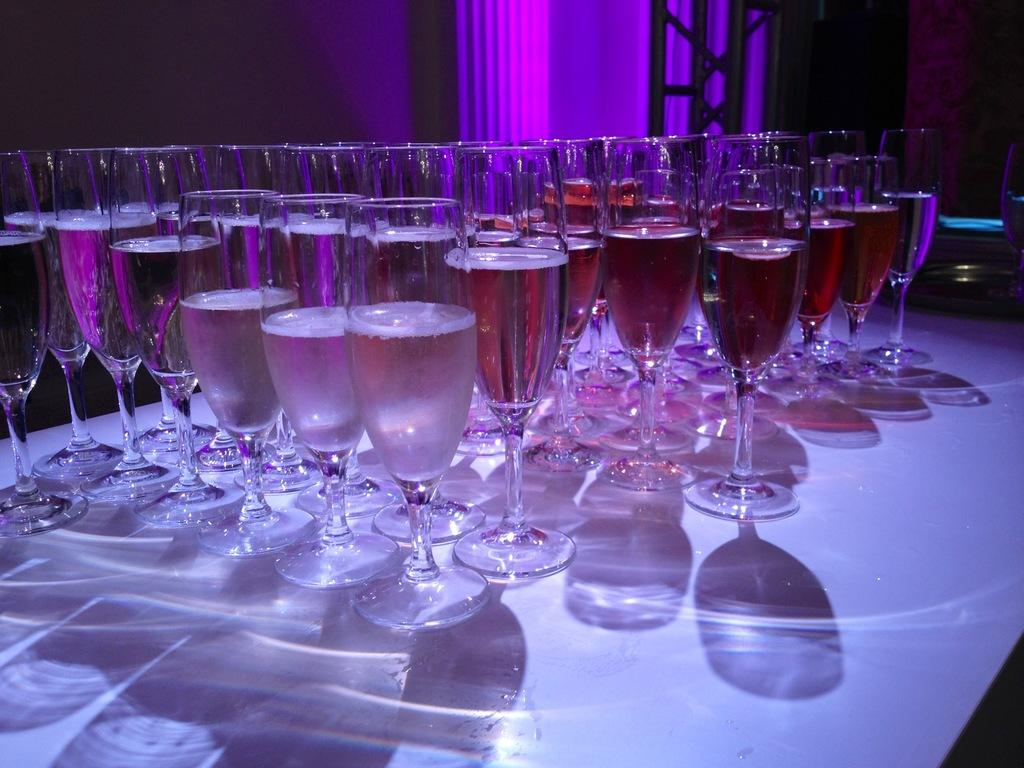What is the main object in the center of the image? There is a table in the center of the image. What is placed on the table? There are many glasses on the table. What can be seen in the background of the image? There is a wall in the background of the image. Where is the robin perched in the image? There is no robin present in the image. What type of tray is used to serve the glasses in the image? The image does not show a tray being used to serve the glasses. 